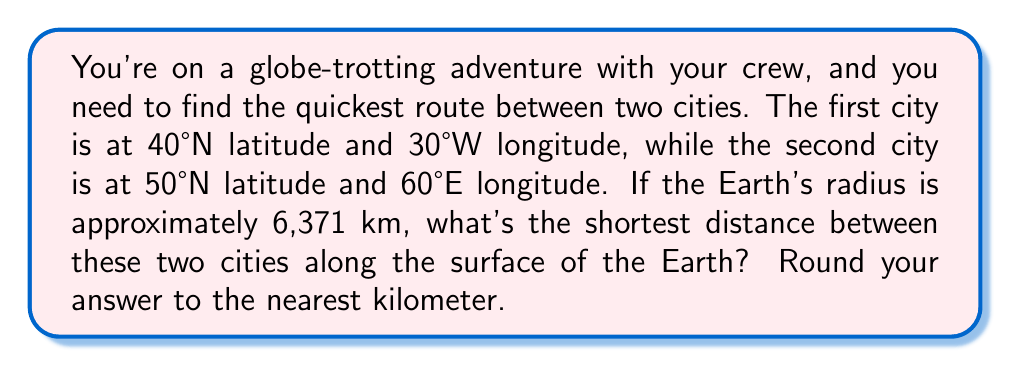Provide a solution to this math problem. Let's break this down step-by-step:

1) The shortest path between two points on a sphere is along a great circle, which is called the geodesic. We can calculate this using the spherical law of cosines.

2) The formula for the central angle $\theta$ between two points on a sphere is:

   $$\cos(\theta) = \sin(\phi_1)\sin(\phi_2) + \cos(\phi_1)\cos(\phi_2)\cos(\Delta\lambda)$$

   Where:
   - $\phi_1$ and $\phi_2$ are the latitudes of the two points
   - $\Delta\lambda$ is the absolute difference in longitude

3) Convert the coordinates to radians:
   - $\phi_1 = 40°N = \frac{40\pi}{180} \approx 0.6981$ radians
   - $\phi_2 = 50°N = \frac{50\pi}{180} \approx 0.8727$ radians
   - $\lambda_1 = 30°W = -\frac{30\pi}{180} \approx -0.5236$ radians
   - $\lambda_2 = 60°E = \frac{60\pi}{180} \approx 1.0472$ radians

4) Calculate $\Delta\lambda$:
   $\Delta\lambda = |\lambda_2 - \lambda_1| = |1.0472 - (-0.5236)| = 1.5708$ radians

5) Apply the formula:
   $$\begin{align}
   \cos(\theta) &= \sin(0.6981)\sin(0.8727) + \cos(0.6981)\cos(0.8727)\cos(1.5708) \\
   &\approx 0.3987
   \end{align}$$

6) Solve for $\theta$:
   $$\theta = \arccos(0.3987) \approx 1.1635 \text{ radians}$$

7) The distance $d$ along the great circle is:
   $$d = R\theta$$
   Where $R$ is the Earth's radius (6,371 km)

8) Calculate the distance:
   $$d = 6371 \times 1.1635 \approx 7412.7 \text{ km}$$

9) Rounding to the nearest kilometer:
   $$d \approx 7413 \text{ km}$$
Answer: 7413 km 